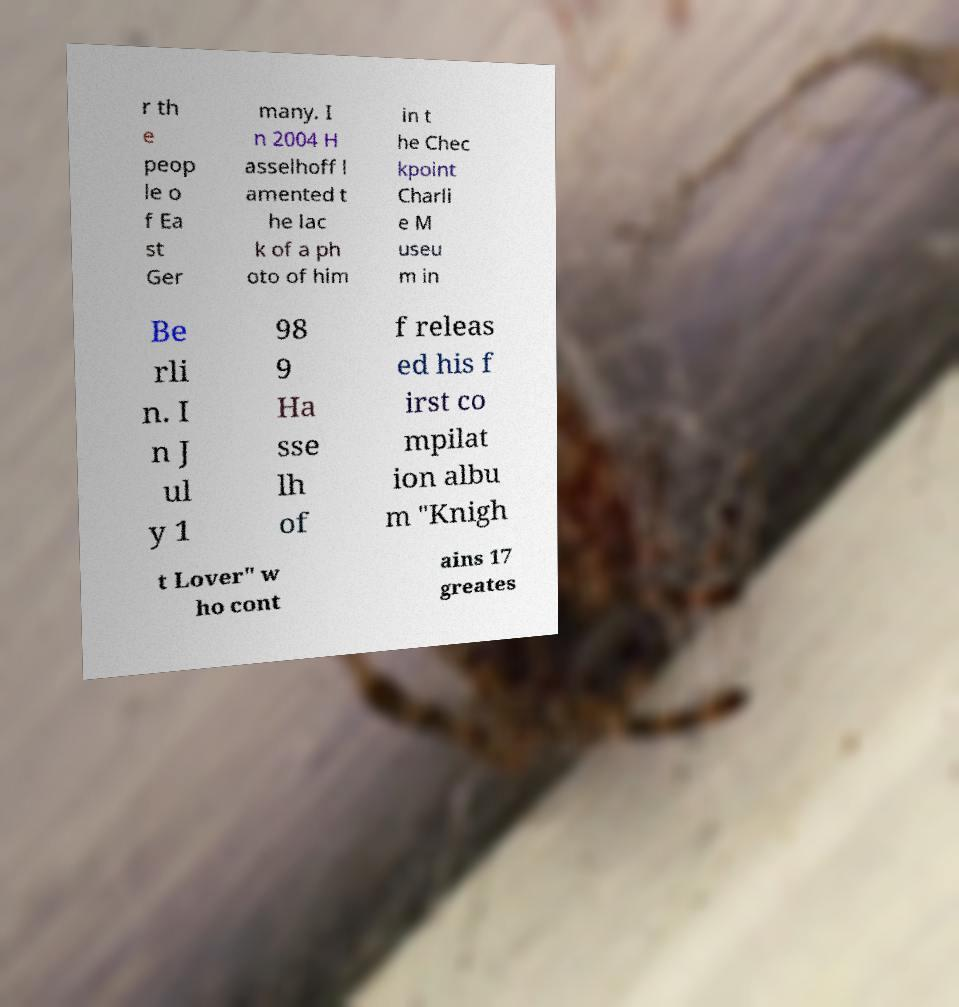Can you read and provide the text displayed in the image?This photo seems to have some interesting text. Can you extract and type it out for me? r th e peop le o f Ea st Ger many. I n 2004 H asselhoff l amented t he lac k of a ph oto of him in t he Chec kpoint Charli e M useu m in Be rli n. I n J ul y 1 98 9 Ha sse lh of f releas ed his f irst co mpilat ion albu m "Knigh t Lover" w ho cont ains 17 greates 